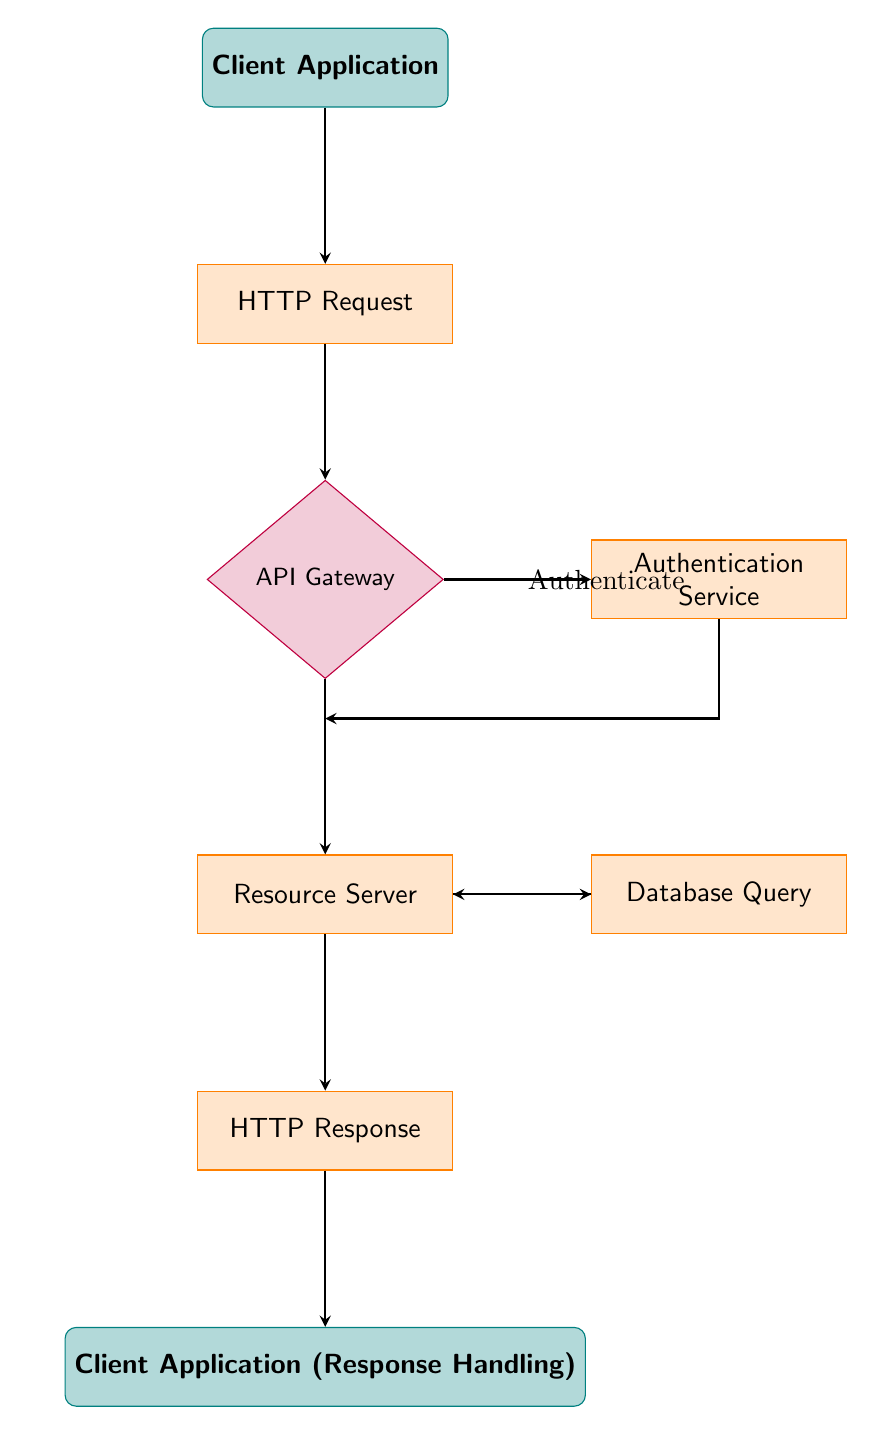What is the starting point of the API request-response cycle? The starting point of the cycle is the "Client Application," where the user initiates the request.
Answer: Client Application How many process nodes are in the diagram? The process nodes in the diagram are "HTTP Request," "Authentication Service," "Resource Server," "Database Query," and "HTTP Response," which totals to five.
Answer: 5 What decision does the API Gateway make? The API Gateway checks for authentication and routes requests accordingly.
Answer: Authenticate Which node comes after the HTTP Request node? After the "HTTP Request" node, the next node is the "API Gateway."
Answer: API Gateway What does the Resource Server do in this cycle? The Resource Server processes the request, fetching necessary data or performing operations to fulfill the request.
Answer: Processes the request Explain the flow from the Client Application to the Client Application (Response Handling). The flow starts at the "Client Application," proceeds to the "HTTP Request," then to the "API Gateway" for routing and authentication. If authenticated, the flow goes to the "Resource Server," which may query the "Database" for data, and finally sends an "HTTP Response" back to the "Client Application (Response Handling)."
Answer: Client Application to HTTP Request to API Gateway to Resource Server to Database Query to HTTP Response to Client Application (Response Handling) What type of service is the Authentication Service? The Authentication Service is a type of process that validates user credentials and issues tokens upon successful validation.
Answer: Process What happens if the credentials are not authenticated at the API Gateway? If credentials are not authenticated, the flow will not proceed to the "Resource Server," thus preventing the request from being processed further.
Answer: Request is halted How many nodes are involved in this flow chart? The flow chart consists of a total of eight nodes: "Client Application," "HTTP Request," "API Gateway," "Authentication Service," "Resource Server," "Database Query," "HTTP Response," and "Client Application (Response Handling)."
Answer: 8 What is the role of Database Query in this cycle? The role of the Database Query is to retrieve necessary data needed to fulfill the request as processed by the Resource Server.
Answer: Retrieve data 